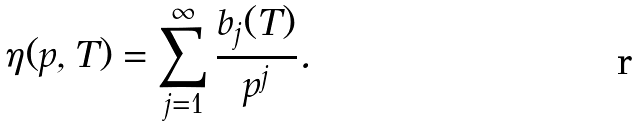<formula> <loc_0><loc_0><loc_500><loc_500>\eta ( p , T ) = \sum _ { j = 1 } ^ { \infty } \frac { b _ { j } ( T ) } { p ^ { j } } .</formula> 